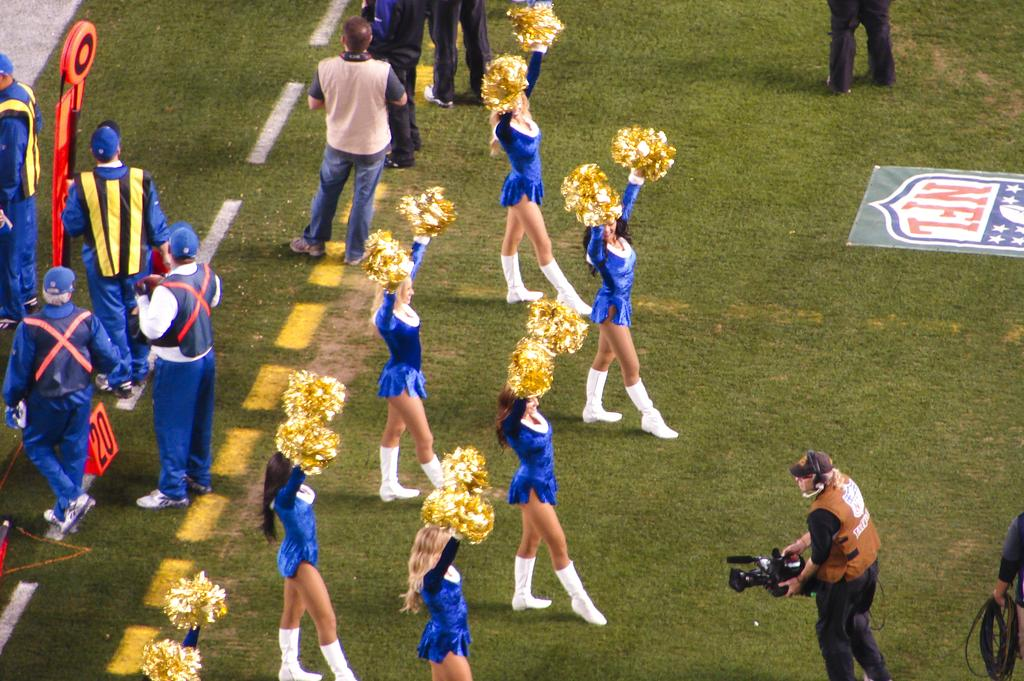Provide a one-sentence caption for the provided image. Cheerleaders are on a football field with the NFL logo on the ground. 